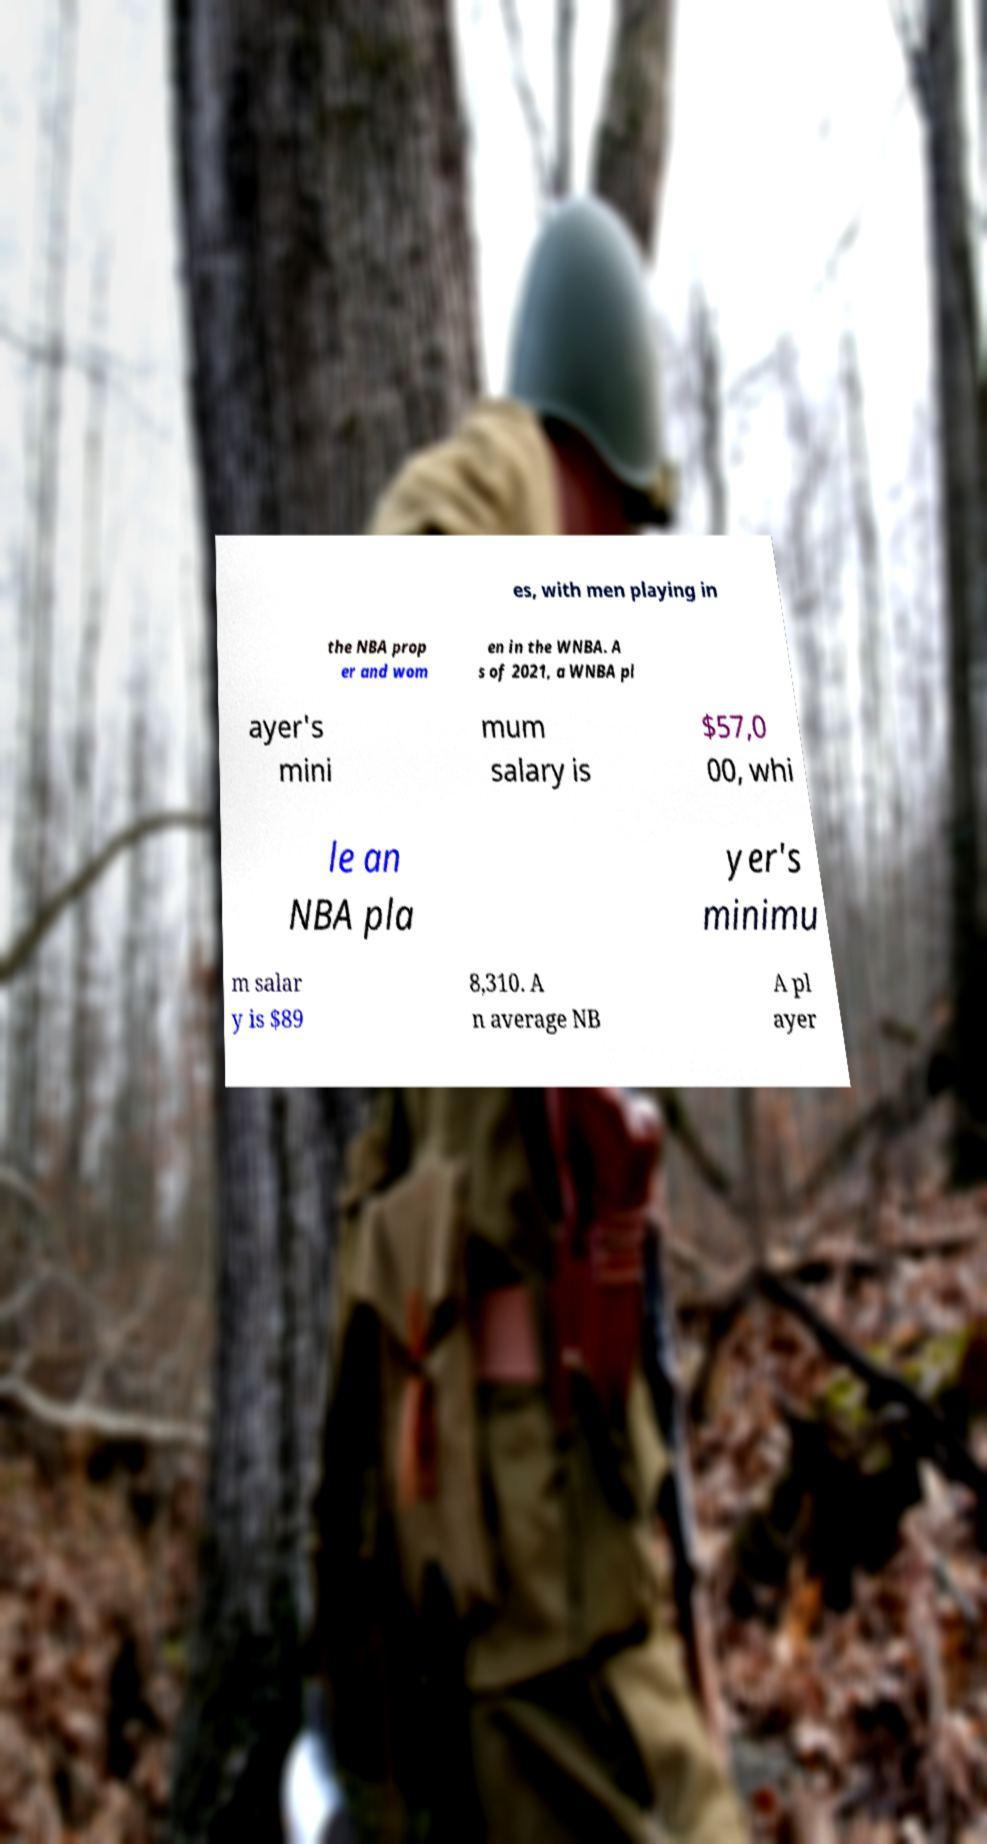What messages or text are displayed in this image? I need them in a readable, typed format. es, with men playing in the NBA prop er and wom en in the WNBA. A s of 2021, a WNBA pl ayer's mini mum salary is $57,0 00, whi le an NBA pla yer's minimu m salar y is $89 8,310. A n average NB A pl ayer 